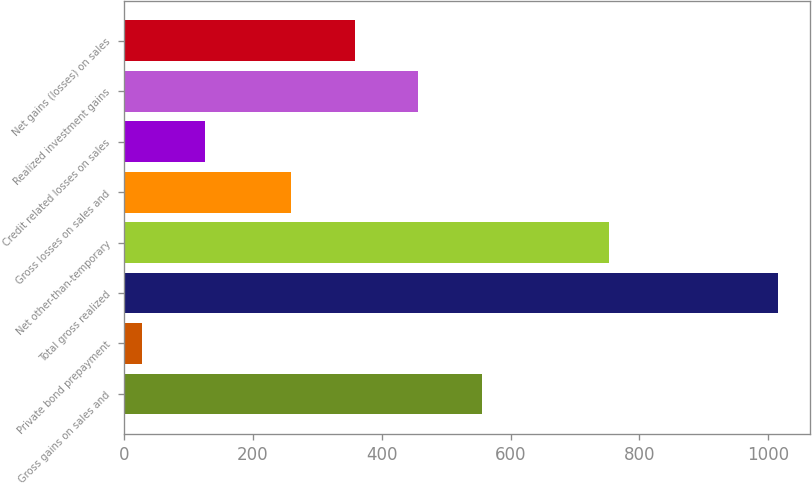Convert chart. <chart><loc_0><loc_0><loc_500><loc_500><bar_chart><fcel>Gross gains on sales and<fcel>Private bond prepayment<fcel>Total gross realized<fcel>Net other-than-temporary<fcel>Gross losses on sales and<fcel>Credit related losses on sales<fcel>Realized investment gains<fcel>Net gains (losses) on sales<nl><fcel>555.4<fcel>27<fcel>1015<fcel>753<fcel>259<fcel>125.8<fcel>456.6<fcel>357.8<nl></chart> 